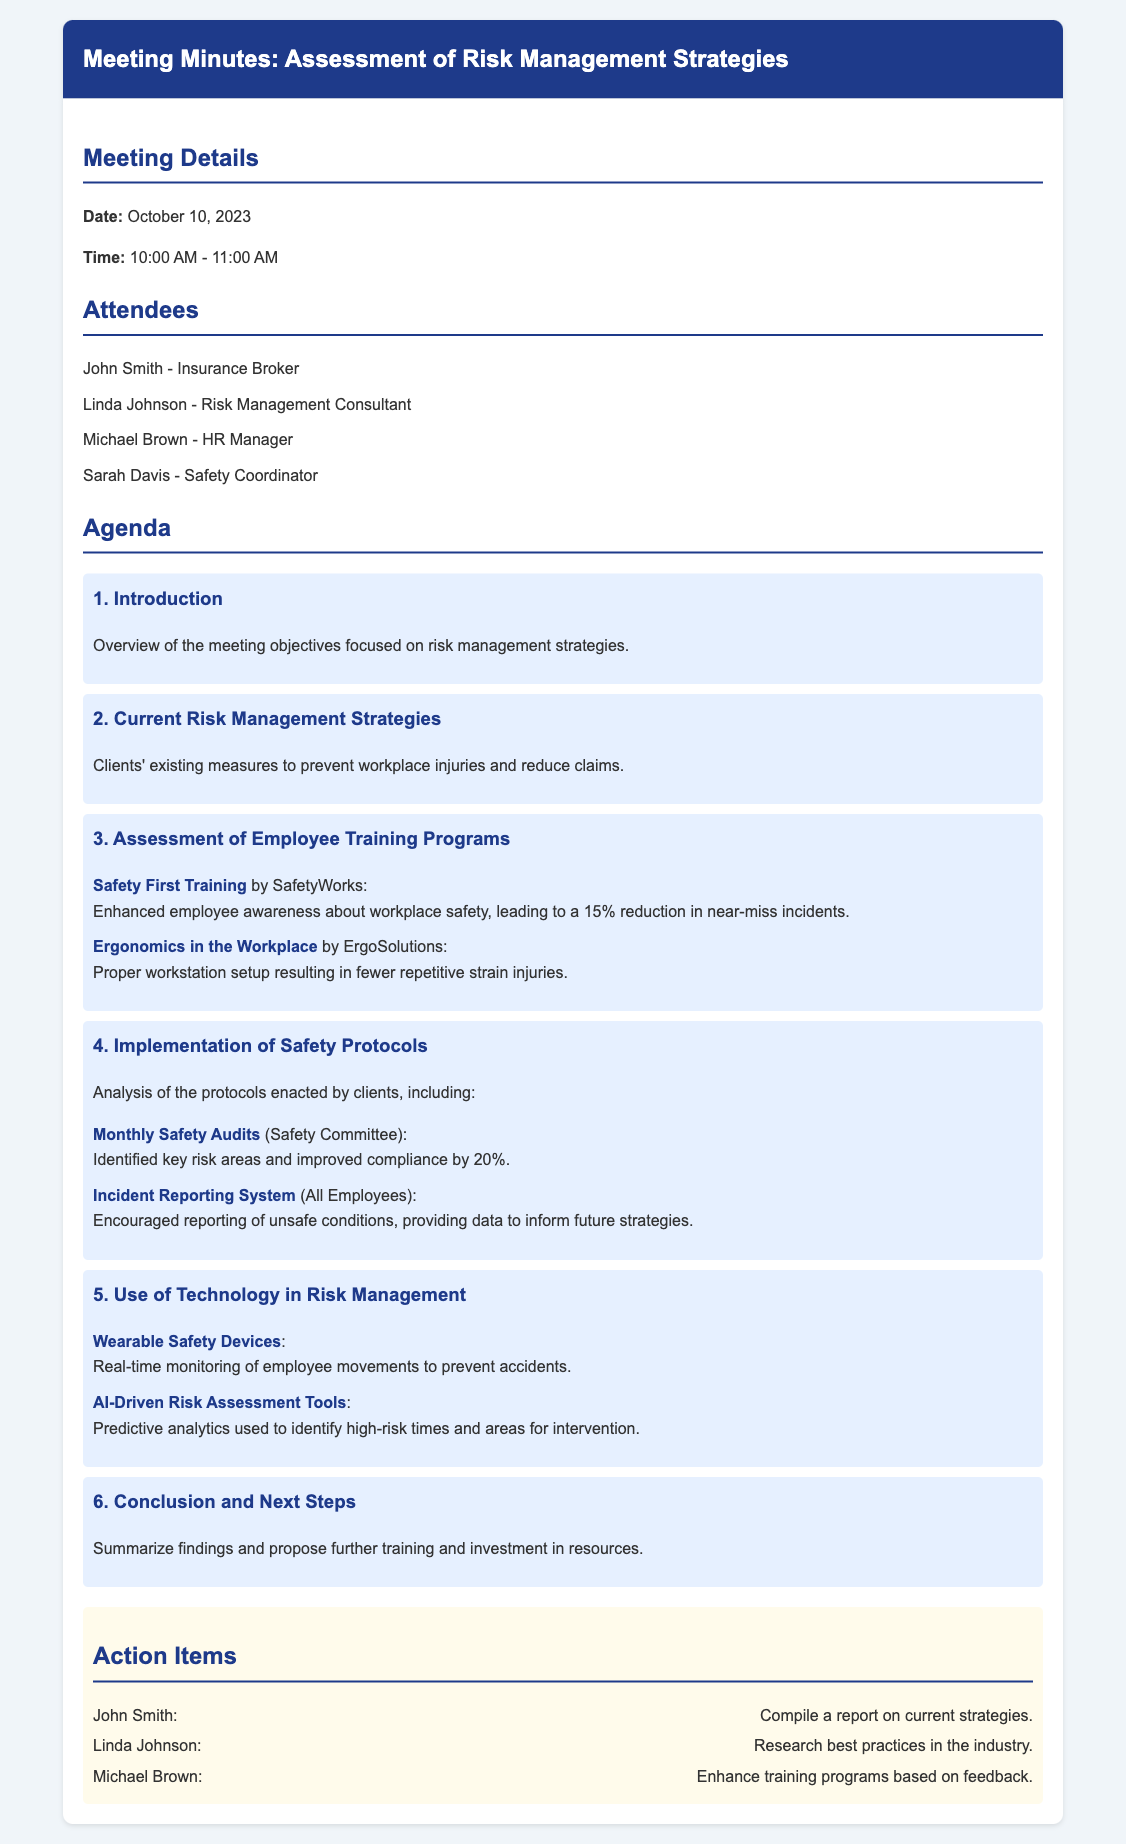What date was the meeting held? The meeting was held on October 10, 2023, as stated in the meeting details.
Answer: October 10, 2023 Who compiled the report on current strategies? John Smith is assigned to compile a report on current strategies in the action items section.
Answer: John Smith What percentage reduction in near-miss incidents was achieved through Safety First Training? The document states a 15% reduction in near-miss incidents due to Safety First Training.
Answer: 15% What was identified through the Monthly Safety Audits? The Monthly Safety Audits identified key risk areas and improved compliance by 20%.
Answer: Key risk areas What type of devices are used for real-time monitoring of employee movements? The document mentions Wearable Safety Devices as technology used for monitoring employee movements.
Answer: Wearable Safety Devices Which attendee is responsible for researching best practices in the industry? Linda Johnson is tasked with researching best practices in the action items.
Answer: Linda Johnson What safety training program is focused on workstation setup? The Ergonomics in the Workplace program by ErgoSolutions focuses on workstation setup.
Answer: Ergonomics in the Workplace How often are safety audits conducted? The Monthly Safety Audits indicate these are conducted every month.
Answer: Monthly 